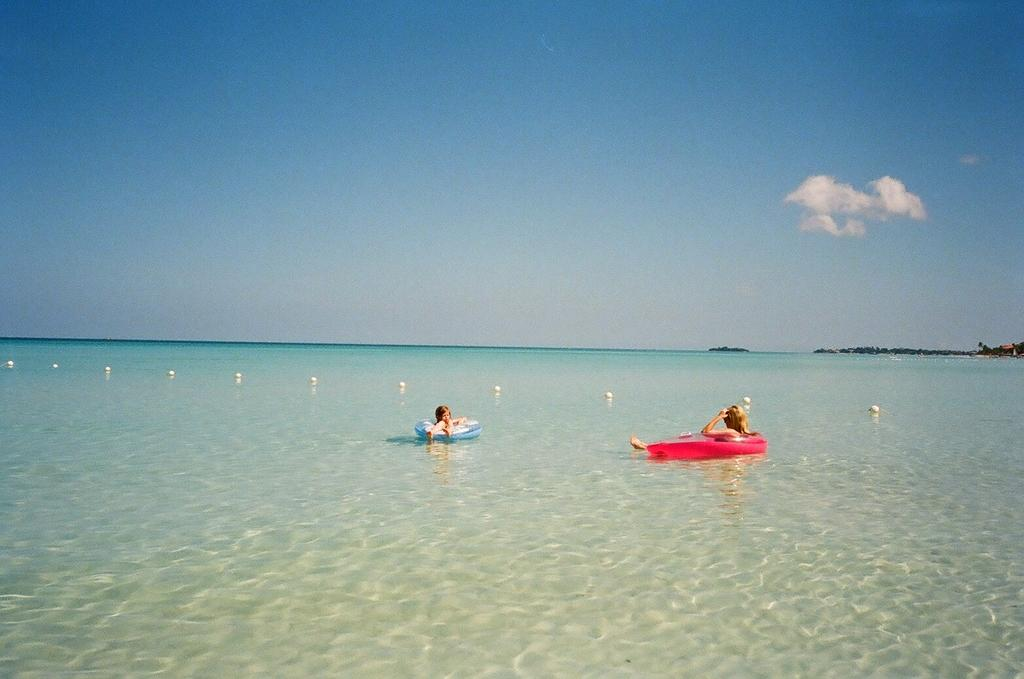How many people are in the image? There are two people in the image. What are the people sitting on? The people are sitting on inflatable tubes. Where are the tubes located? The tubes are on a river. What can be seen in the background of the image? There are trees and the sky visible in the background of the image. Can you tell me how many times the person on the left sneezes in the image? There is no indication in the image that anyone is sneezing, so it cannot be determined from the picture. 